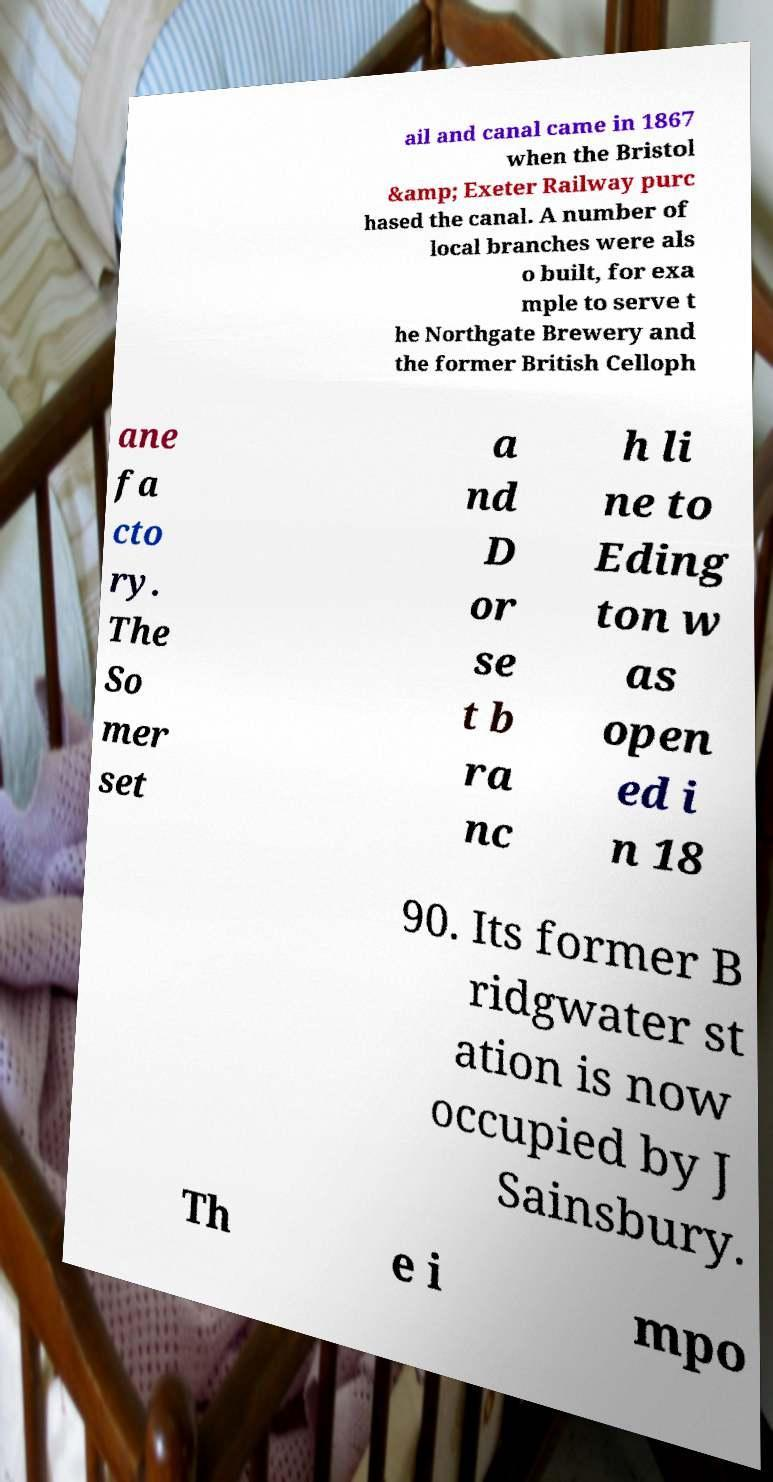I need the written content from this picture converted into text. Can you do that? ail and canal came in 1867 when the Bristol &amp; Exeter Railway purc hased the canal. A number of local branches were als o built, for exa mple to serve t he Northgate Brewery and the former British Celloph ane fa cto ry. The So mer set a nd D or se t b ra nc h li ne to Eding ton w as open ed i n 18 90. Its former B ridgwater st ation is now occupied by J Sainsbury. Th e i mpo 